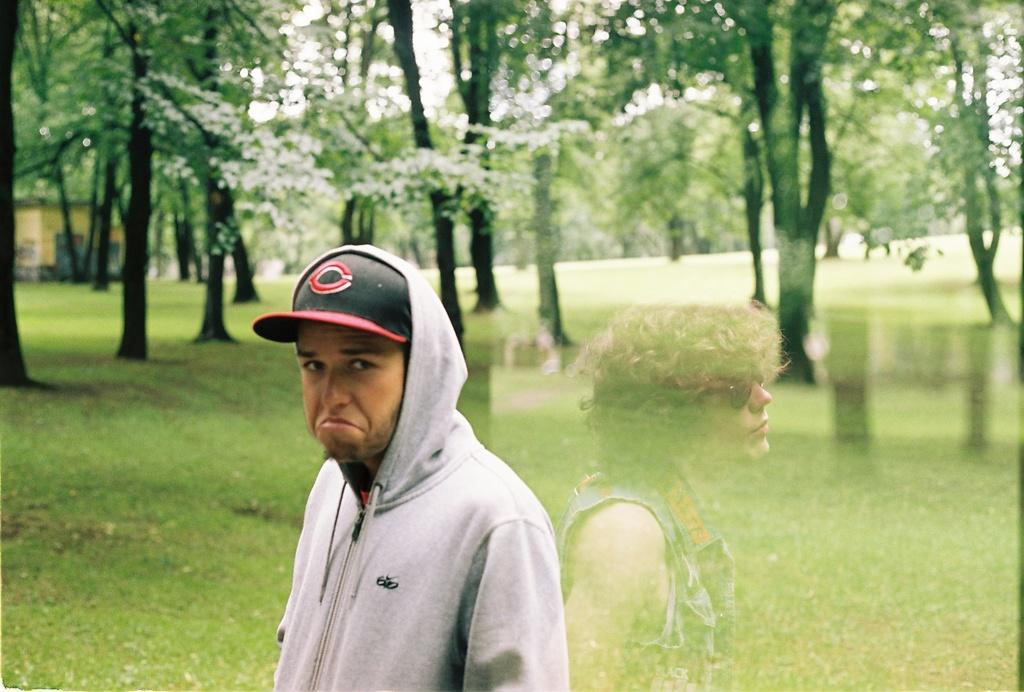Who is the main subject in the image? There is a man in the center of the image. What can be seen in the background of the image? There are trees, grass, a house, and the sky visible in the background of the image. How many horses are present in the image? There are no horses present in the image. Are there any babies visible in the image? There is no mention of babies in the image, and they are not visible. 